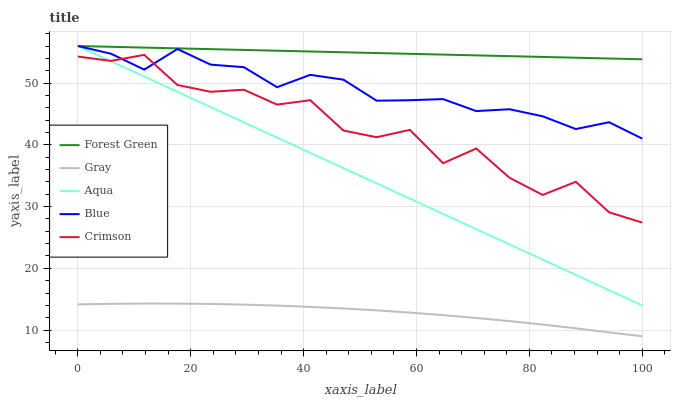Does Forest Green have the minimum area under the curve?
Answer yes or no. No. Does Gray have the maximum area under the curve?
Answer yes or no. No. Is Gray the smoothest?
Answer yes or no. No. Is Gray the roughest?
Answer yes or no. No. Does Forest Green have the lowest value?
Answer yes or no. No. Does Gray have the highest value?
Answer yes or no. No. Is Gray less than Blue?
Answer yes or no. Yes. Is Forest Green greater than Crimson?
Answer yes or no. Yes. Does Gray intersect Blue?
Answer yes or no. No. 